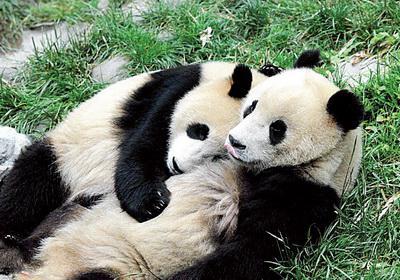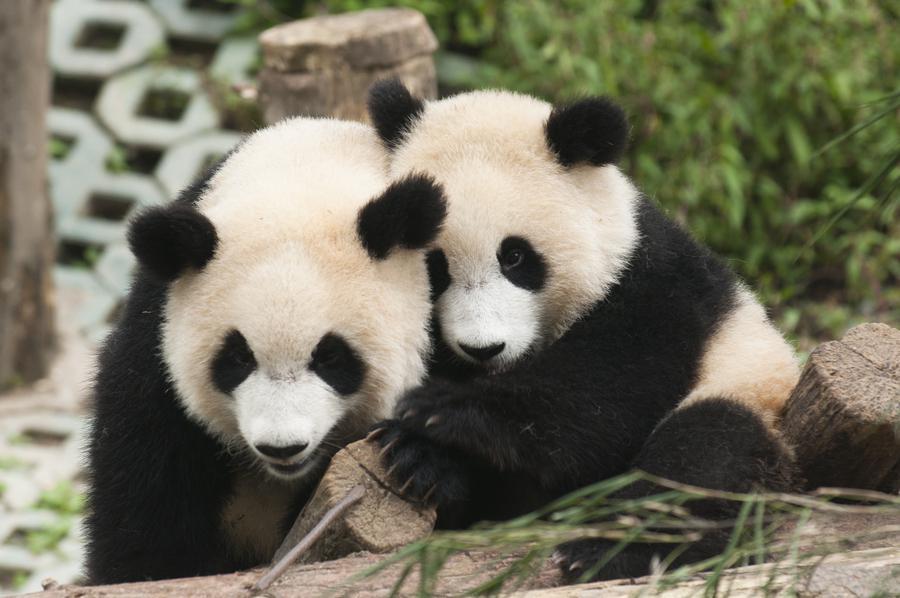The first image is the image on the left, the second image is the image on the right. Examine the images to the left and right. Is the description "There is at least one baby panda on top of grass looking forward" accurate? Answer yes or no. No. The first image is the image on the left, the second image is the image on the right. For the images shown, is this caption "There are no panda-pups in the left image." true? Answer yes or no. Yes. 